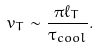Convert formula to latex. <formula><loc_0><loc_0><loc_500><loc_500>v _ { T } \sim \frac { \pi \ell _ { T } } { \tau _ { c o o l } } .</formula> 